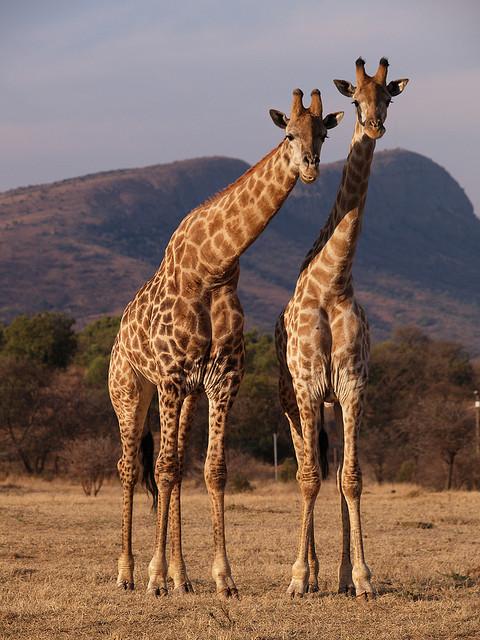How many giraffes are looking at the camera?
Give a very brief answer. 2. Where are the giraffes?
Write a very short answer. Field. How many giraffes are facing the camera?
Keep it brief. 2. Are the giraffes happy?
Quick response, please. Yes. How many giraffes?
Give a very brief answer. 2. What color is the grass?
Give a very brief answer. Brown. How many animals are shown?
Short answer required. 2. 